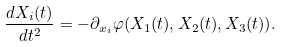<formula> <loc_0><loc_0><loc_500><loc_500>\frac { d X _ { i } ( t ) } { d t ^ { 2 } } = - \partial _ { x _ { i } } \varphi ( X _ { 1 } ( t ) , X _ { 2 } ( t ) , X _ { 3 } ( t ) ) .</formula> 